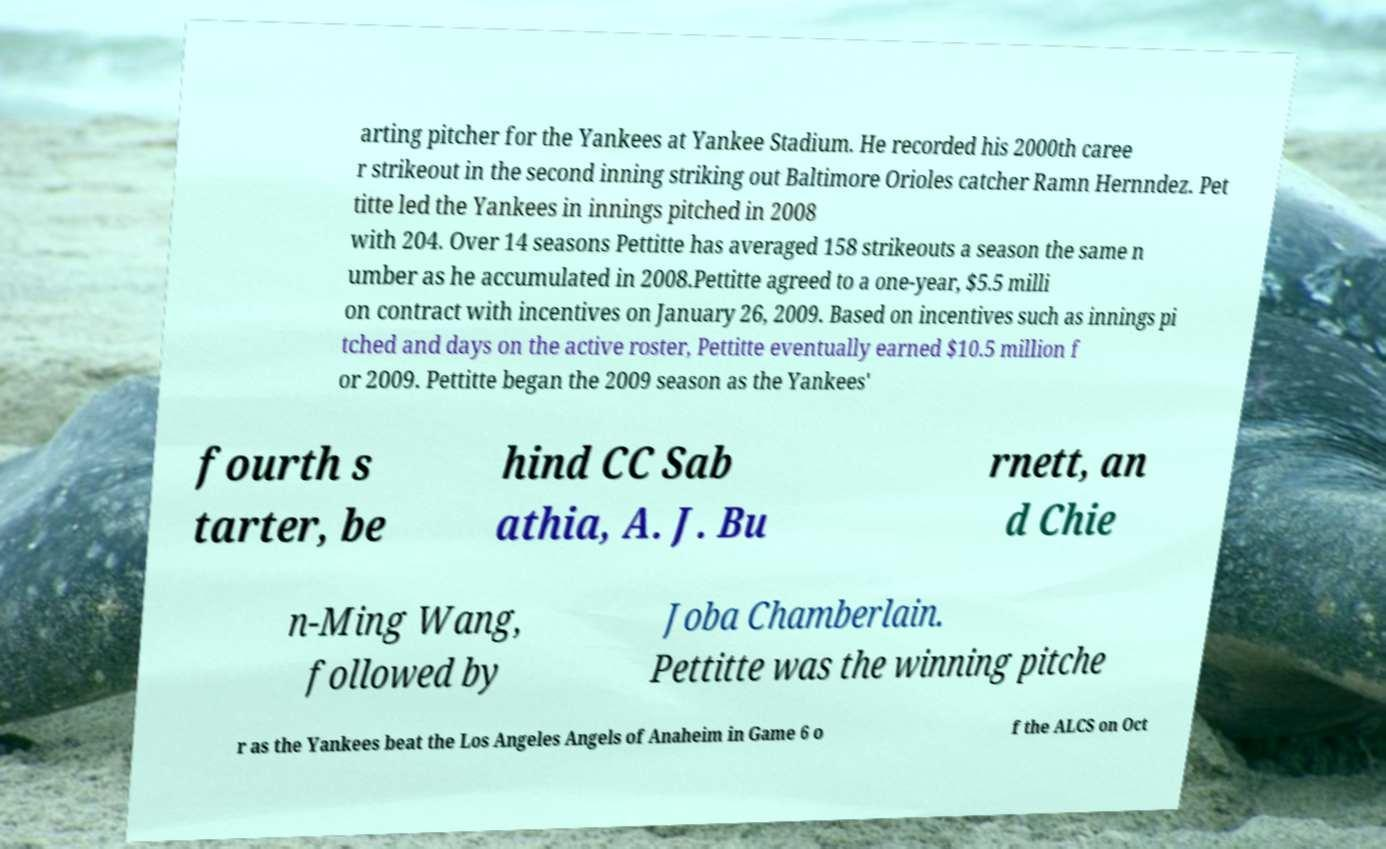Could you assist in decoding the text presented in this image and type it out clearly? arting pitcher for the Yankees at Yankee Stadium. He recorded his 2000th caree r strikeout in the second inning striking out Baltimore Orioles catcher Ramn Hernndez. Pet titte led the Yankees in innings pitched in 2008 with 204. Over 14 seasons Pettitte has averaged 158 strikeouts a season the same n umber as he accumulated in 2008.Pettitte agreed to a one-year, $5.5 milli on contract with incentives on January 26, 2009. Based on incentives such as innings pi tched and days on the active roster, Pettitte eventually earned $10.5 million f or 2009. Pettitte began the 2009 season as the Yankees' fourth s tarter, be hind CC Sab athia, A. J. Bu rnett, an d Chie n-Ming Wang, followed by Joba Chamberlain. Pettitte was the winning pitche r as the Yankees beat the Los Angeles Angels of Anaheim in Game 6 o f the ALCS on Oct 